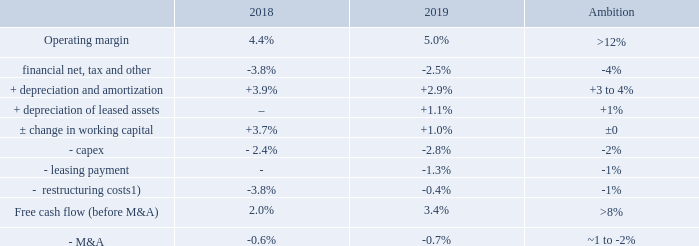Free cash flow generation
Bridge from operating income to free cash flow (illustrative)
Focus on delivering a high conversion of operating income to free cash flow of operating income to free cash flow
of operating income to free cash flow
Ongoing activities to reduce costs “below operating income”, including restructuring, financial net and tax
Striving to maintain working capital efficiency but fluctuations may impact cash flow
Planning assumption for capex is about 2% of net sales, while expected to remain above 2% in 2020 due to the new factory in the US
Ambition to over time maintain restructuring charges to around 1% of net sales
M&A will vary depending on strategic decisions but assumed to be around 1–2% of net sales
Operating margin excluding restructuring charges. All numbers are in relation to net sales.
1) Restructuring charges as reported in the income statement for each year.
What is the operating margin in 2018? 4.4%. What is the operating margin in 2019? 5.0%. What is the M&A cash flow percentage in 2019? -0.7%. What is the change in capex between 2018 and 2019?
Answer scale should be: percent. -2.4- (-2.8) 
Answer: 0.4. Which year has a higher free cash flow (before M&A)? 3.4%>2.0%
Answer: 2019. What is the change in operating margin between 2018 and 2019?
Answer scale should be: percent. 5.0-4.4
Answer: 0.6. 